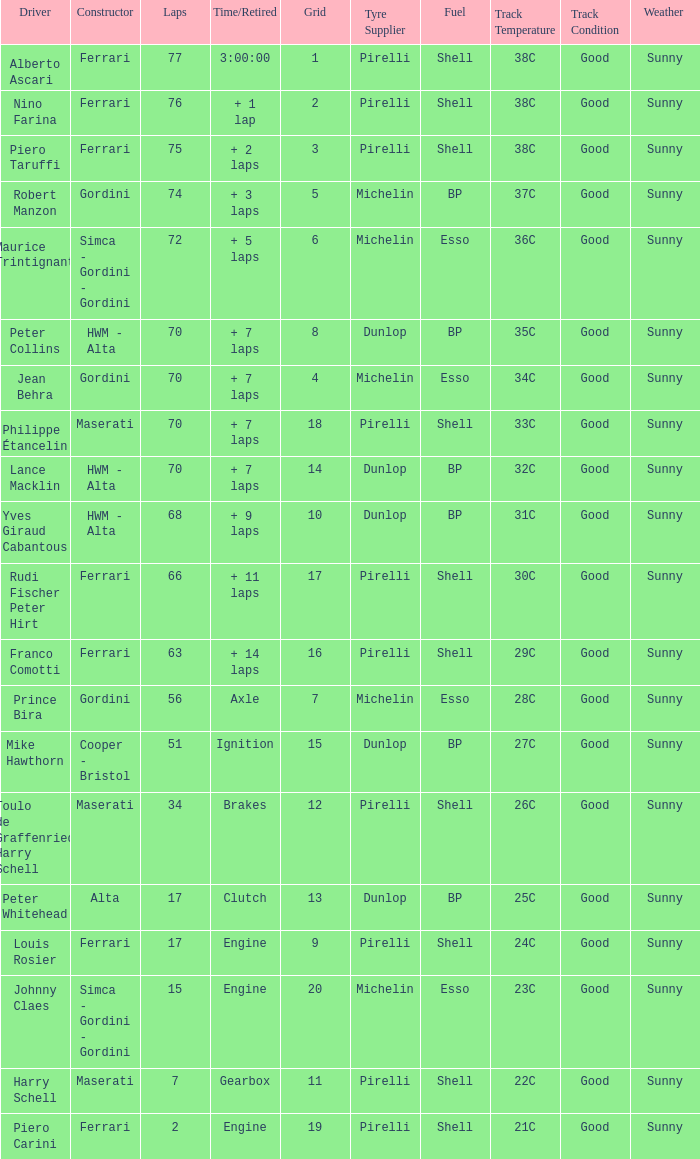Who drove the car with over 66 laps with a grid of 5? Robert Manzon. 